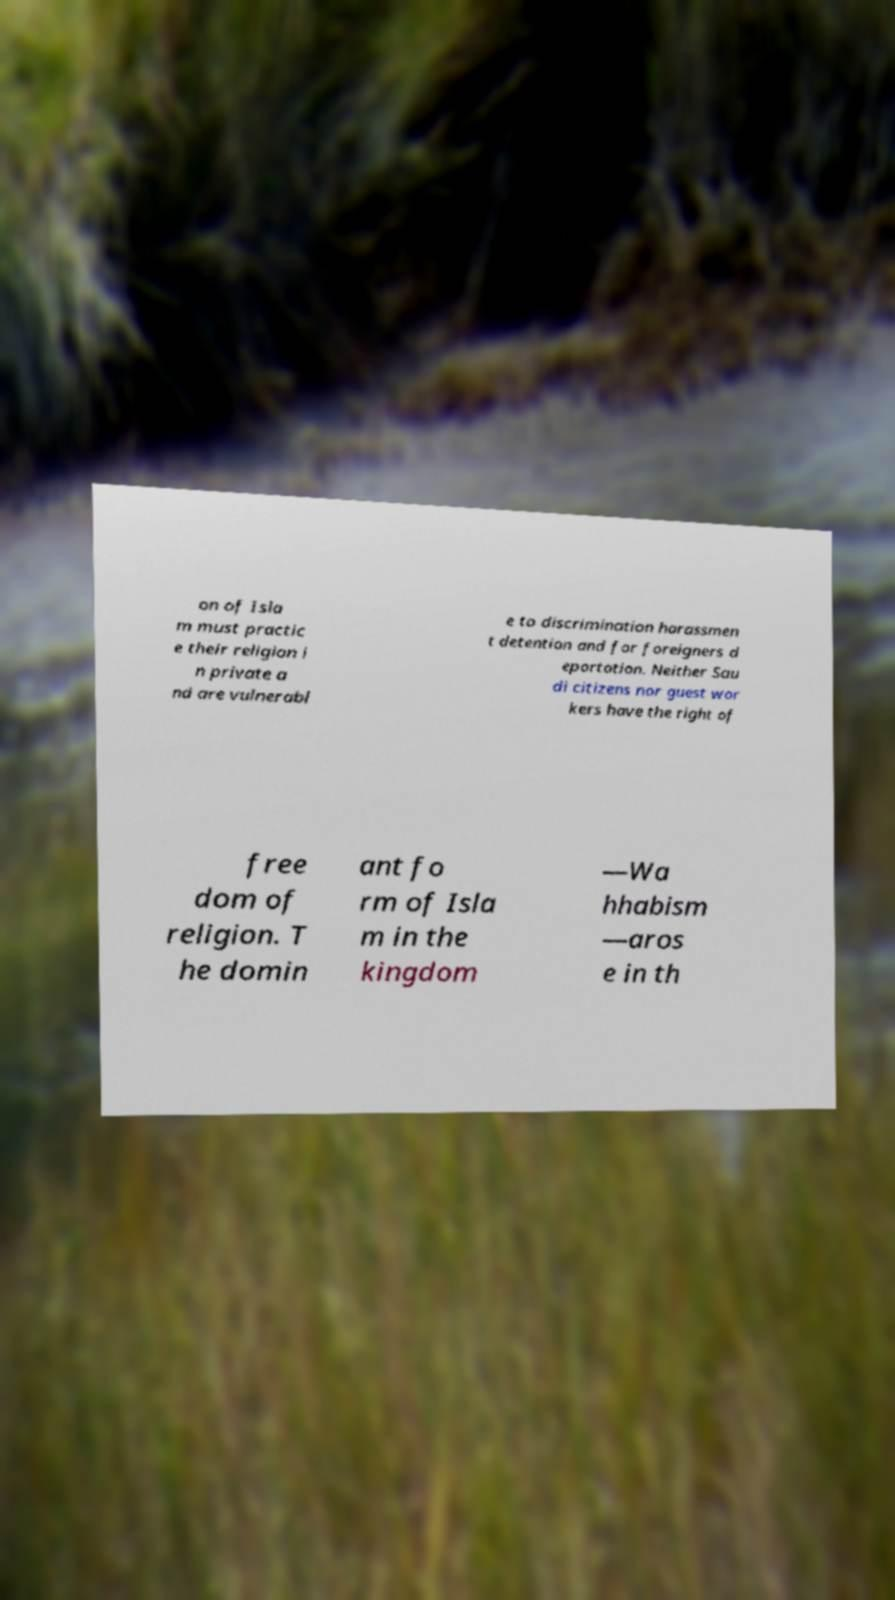I need the written content from this picture converted into text. Can you do that? on of Isla m must practic e their religion i n private a nd are vulnerabl e to discrimination harassmen t detention and for foreigners d eportation. Neither Sau di citizens nor guest wor kers have the right of free dom of religion. T he domin ant fo rm of Isla m in the kingdom —Wa hhabism —aros e in th 